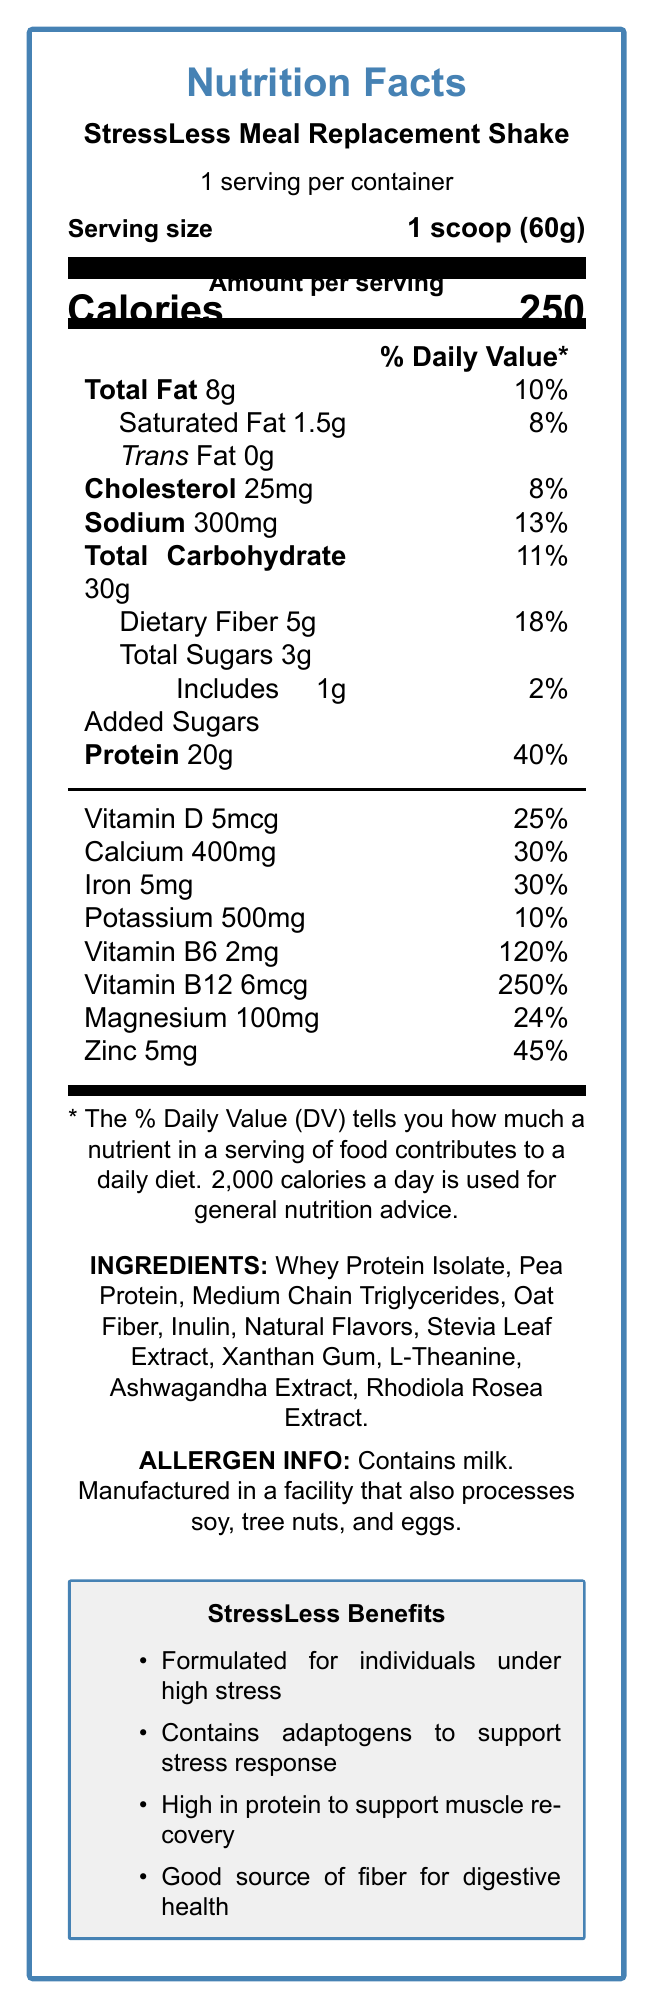what is the serving size for the StressLess Meal Replacement Shake? The serving size is explicitly mentioned as "1 scoop (60g)" under the "Serving size" section.
Answer: 1 scoop (60g) how many calories are there per serving? The "Amount per serving" section lists the calories as 250.
Answer: 250 calories what percentage of the daily value does the protein content represent? The protein content is listed as "40%" under the "Protein" section.
Answer: 40% which vitamin has the highest percentage of the daily value? The "Vitamin B12" percentage is the highest at 250%, as shown in the document.
Answer: Vitamin B12 what are the allergen warnings associated with the shake? The allergen information is explicitly stated under the "ALLERGEN INFO" section.
Answer: Contains milk. Manufactured in a facility that also processes soy, tree nuts, and eggs. which minerals are listed with their Daily Value percentages? A. Magnesium, Vitamin D, Zinc B. Calcium, Iron, Potassium C. Vitamin B6, Vitamin B12, Potassium D. Iron, Magnesium, Zinc The minerals listed with percentages of their Daily Value are Calcium (30%), Iron (30%), and Potassium (10%).
Answer: B. Calcium, Iron, Potassium how much dietary fiber does one serving contain? The "Dietary Fiber" section lists it as 5g with an 18% Daily Value.
Answer: 5g how much of the total carbohydrate is from added sugars? A. 0g B. 1g C. 2g D. 3g The label indicates that 1g of the total carbohydrate is from added sugars.
Answer: B. 1g is there any trans fat in the shake? The "Trans Fat" section lists the amount as 0g.
Answer: No which adaptogenic herbs are included in the ingredients? These adaptogens are specifically mentioned in the "INGREDIENTS" section.
Answer: Ashwagandha Extract, Rhodiola Rosea Extract what is the overall purpose of the StressLess Meal Replacement Shake based on the document? The document highlights benefits like "Formulated for individuals under high stress" and mentions adaptogens, protein, and fiber contributions.
Answer: To support individuals under high stress with a balanced nutritional profile, including adaptogens, high protein, and fiber how is the product intended to support cognitive function and stress recovery in law enforcement personnel? The document lacks specific details on mechanisms or studies relating to cognitive function and stress recovery in law enforcement personnel.
Answer: Not enough information describe the main idea of the document The document provides comprehensive information about the shake's nutritional values, ingredients, and promoted health benefits, particularly for those experiencing high stress.
Answer: The document presents the Nutrition Facts Label for the StressLess Meal Replacement Shake, detailing its nutritional content, ingredients, allergens, and specific benefits tailored for individuals under high stress. Key components include a focus on high protein, adaptogens for stress response, and fiber for digestive health. what percentage of the daily value of Vitamin D does the shake provide? The "Vitamin D" section lists the daily value percentage as 25%.
Answer: 25% 